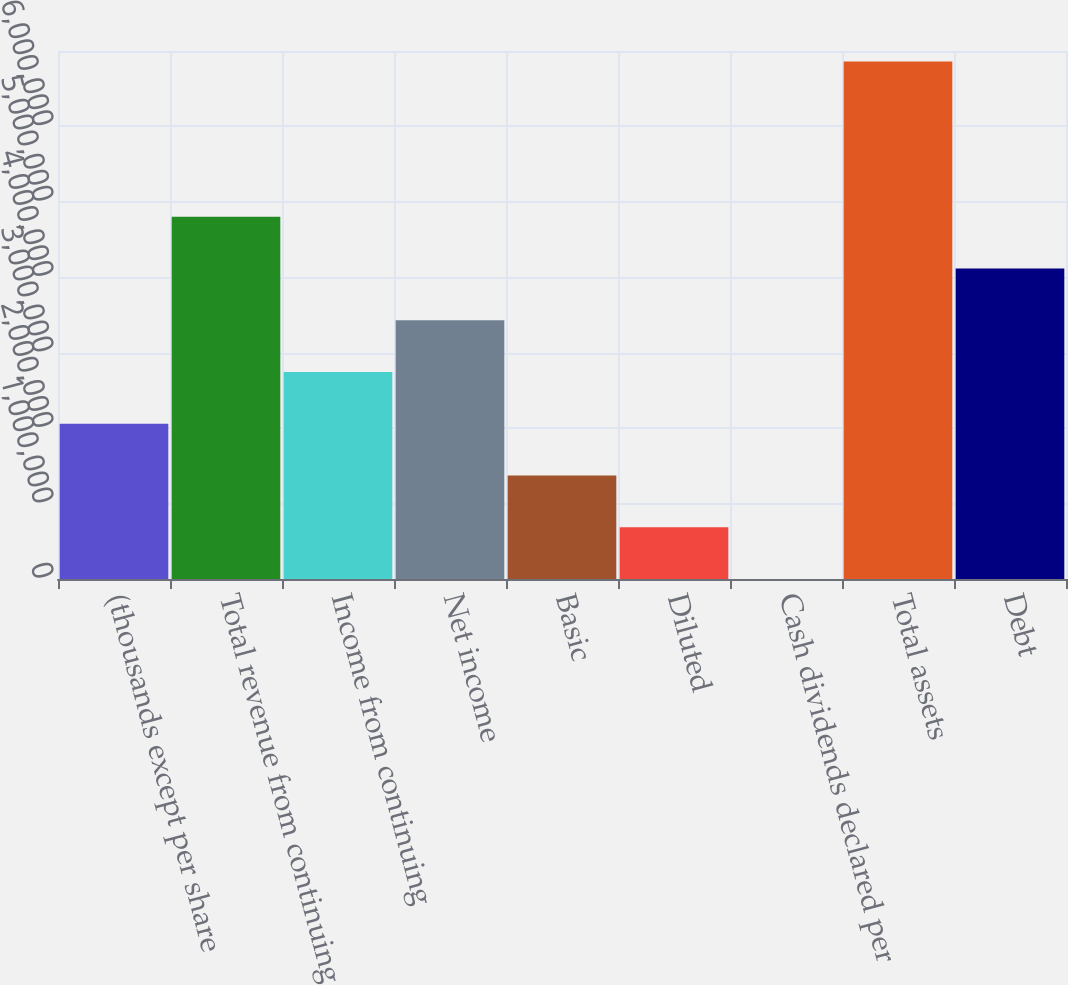Convert chart to OTSL. <chart><loc_0><loc_0><loc_500><loc_500><bar_chart><fcel>(thousands except per share<fcel>Total revenue from continuing<fcel>Income from continuing<fcel>Net income<fcel>Basic<fcel>Diluted<fcel>Cash dividends declared per<fcel>Total assets<fcel>Debt<nl><fcel>2.05791e+06<fcel>4.80178e+06<fcel>2.74388e+06<fcel>3.42985e+06<fcel>1.37194e+06<fcel>685970<fcel>1.45<fcel>6.85969e+06<fcel>4.11581e+06<nl></chart> 